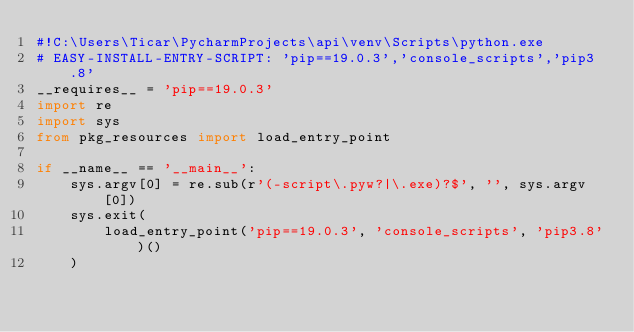Convert code to text. <code><loc_0><loc_0><loc_500><loc_500><_Python_>#!C:\Users\Ticar\PycharmProjects\api\venv\Scripts\python.exe
# EASY-INSTALL-ENTRY-SCRIPT: 'pip==19.0.3','console_scripts','pip3.8'
__requires__ = 'pip==19.0.3'
import re
import sys
from pkg_resources import load_entry_point

if __name__ == '__main__':
    sys.argv[0] = re.sub(r'(-script\.pyw?|\.exe)?$', '', sys.argv[0])
    sys.exit(
        load_entry_point('pip==19.0.3', 'console_scripts', 'pip3.8')()
    )
</code> 